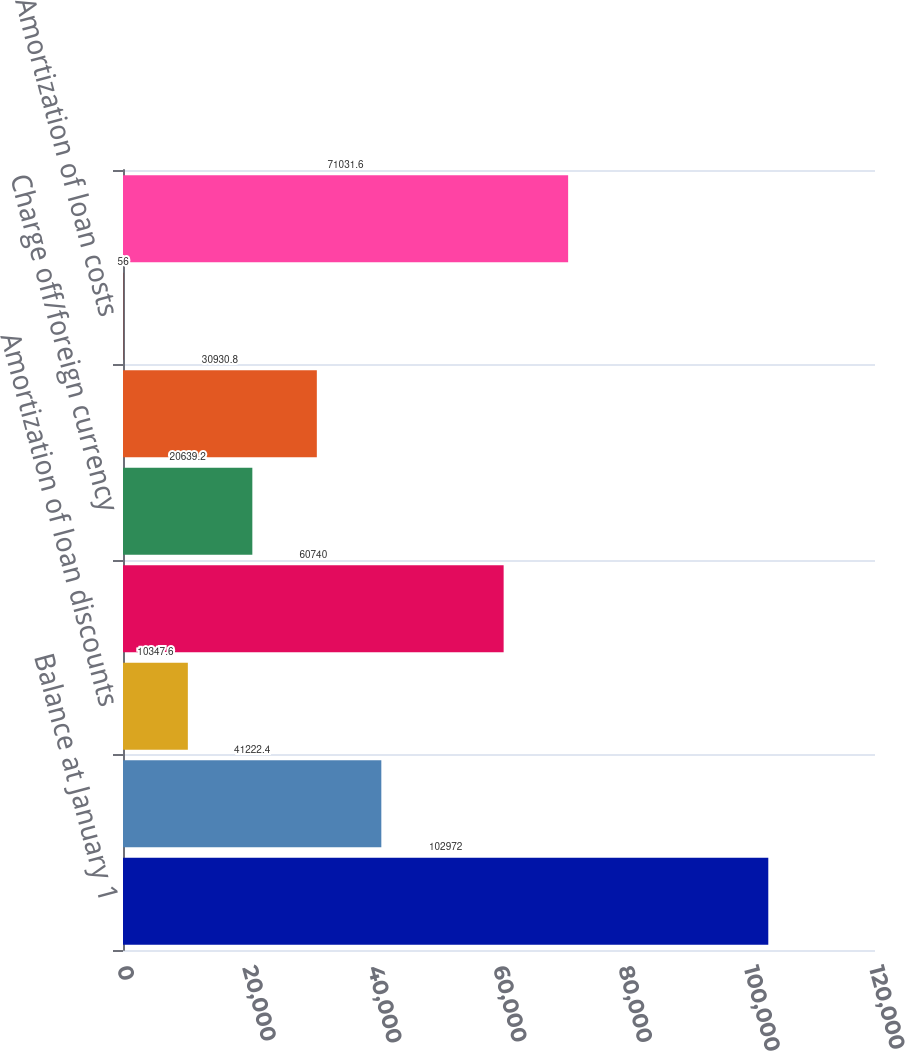Convert chart. <chart><loc_0><loc_0><loc_500><loc_500><bar_chart><fcel>Balance at January 1<fcel>New mortgage loans<fcel>Amortization of loan discounts<fcel>Loan repayments<fcel>Charge off/foreign currency<fcel>Collections of principal<fcel>Amortization of loan costs<fcel>Balance at December 31<nl><fcel>102972<fcel>41222.4<fcel>10347.6<fcel>60740<fcel>20639.2<fcel>30930.8<fcel>56<fcel>71031.6<nl></chart> 